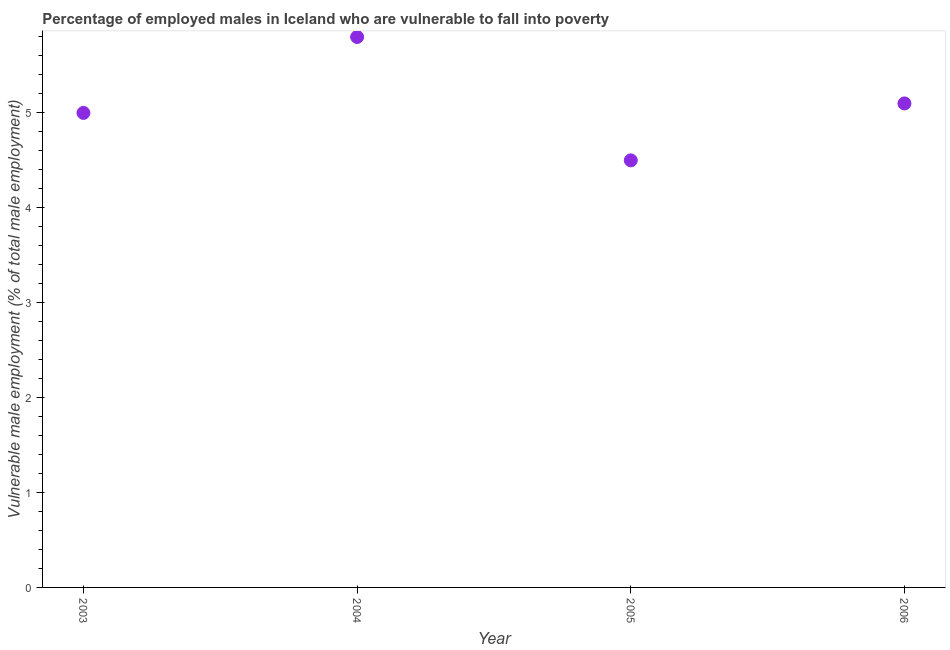What is the percentage of employed males who are vulnerable to fall into poverty in 2006?
Offer a very short reply. 5.1. Across all years, what is the maximum percentage of employed males who are vulnerable to fall into poverty?
Ensure brevity in your answer.  5.8. What is the sum of the percentage of employed males who are vulnerable to fall into poverty?
Give a very brief answer. 20.4. What is the difference between the percentage of employed males who are vulnerable to fall into poverty in 2004 and 2006?
Your answer should be very brief. 0.7. What is the average percentage of employed males who are vulnerable to fall into poverty per year?
Offer a very short reply. 5.1. What is the median percentage of employed males who are vulnerable to fall into poverty?
Keep it short and to the point. 5.05. In how many years, is the percentage of employed males who are vulnerable to fall into poverty greater than 0.6000000000000001 %?
Give a very brief answer. 4. What is the ratio of the percentage of employed males who are vulnerable to fall into poverty in 2003 to that in 2004?
Offer a very short reply. 0.86. What is the difference between the highest and the second highest percentage of employed males who are vulnerable to fall into poverty?
Give a very brief answer. 0.7. What is the difference between the highest and the lowest percentage of employed males who are vulnerable to fall into poverty?
Your response must be concise. 1.3. In how many years, is the percentage of employed males who are vulnerable to fall into poverty greater than the average percentage of employed males who are vulnerable to fall into poverty taken over all years?
Provide a succinct answer. 1. Does the percentage of employed males who are vulnerable to fall into poverty monotonically increase over the years?
Offer a very short reply. No. How many years are there in the graph?
Your response must be concise. 4. What is the difference between two consecutive major ticks on the Y-axis?
Make the answer very short. 1. Does the graph contain any zero values?
Make the answer very short. No. Does the graph contain grids?
Your answer should be compact. No. What is the title of the graph?
Keep it short and to the point. Percentage of employed males in Iceland who are vulnerable to fall into poverty. What is the label or title of the Y-axis?
Offer a very short reply. Vulnerable male employment (% of total male employment). What is the Vulnerable male employment (% of total male employment) in 2004?
Your answer should be very brief. 5.8. What is the Vulnerable male employment (% of total male employment) in 2006?
Offer a very short reply. 5.1. What is the difference between the Vulnerable male employment (% of total male employment) in 2004 and 2006?
Offer a terse response. 0.7. What is the difference between the Vulnerable male employment (% of total male employment) in 2005 and 2006?
Offer a terse response. -0.6. What is the ratio of the Vulnerable male employment (% of total male employment) in 2003 to that in 2004?
Your answer should be compact. 0.86. What is the ratio of the Vulnerable male employment (% of total male employment) in 2003 to that in 2005?
Make the answer very short. 1.11. What is the ratio of the Vulnerable male employment (% of total male employment) in 2004 to that in 2005?
Make the answer very short. 1.29. What is the ratio of the Vulnerable male employment (% of total male employment) in 2004 to that in 2006?
Provide a succinct answer. 1.14. What is the ratio of the Vulnerable male employment (% of total male employment) in 2005 to that in 2006?
Ensure brevity in your answer.  0.88. 